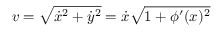<formula> <loc_0><loc_0><loc_500><loc_500>v = \sqrt { \dot { x } ^ { 2 } + \dot { y } ^ { 2 } } = \dot { x } \sqrt { 1 + \phi ^ { \prime } ( x ) ^ { 2 } }</formula> 